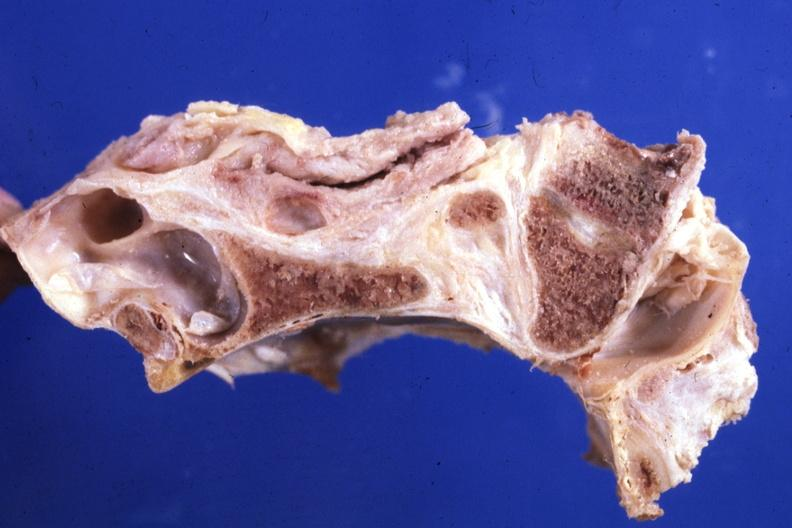what is present?
Answer the question using a single word or phrase. Bone 